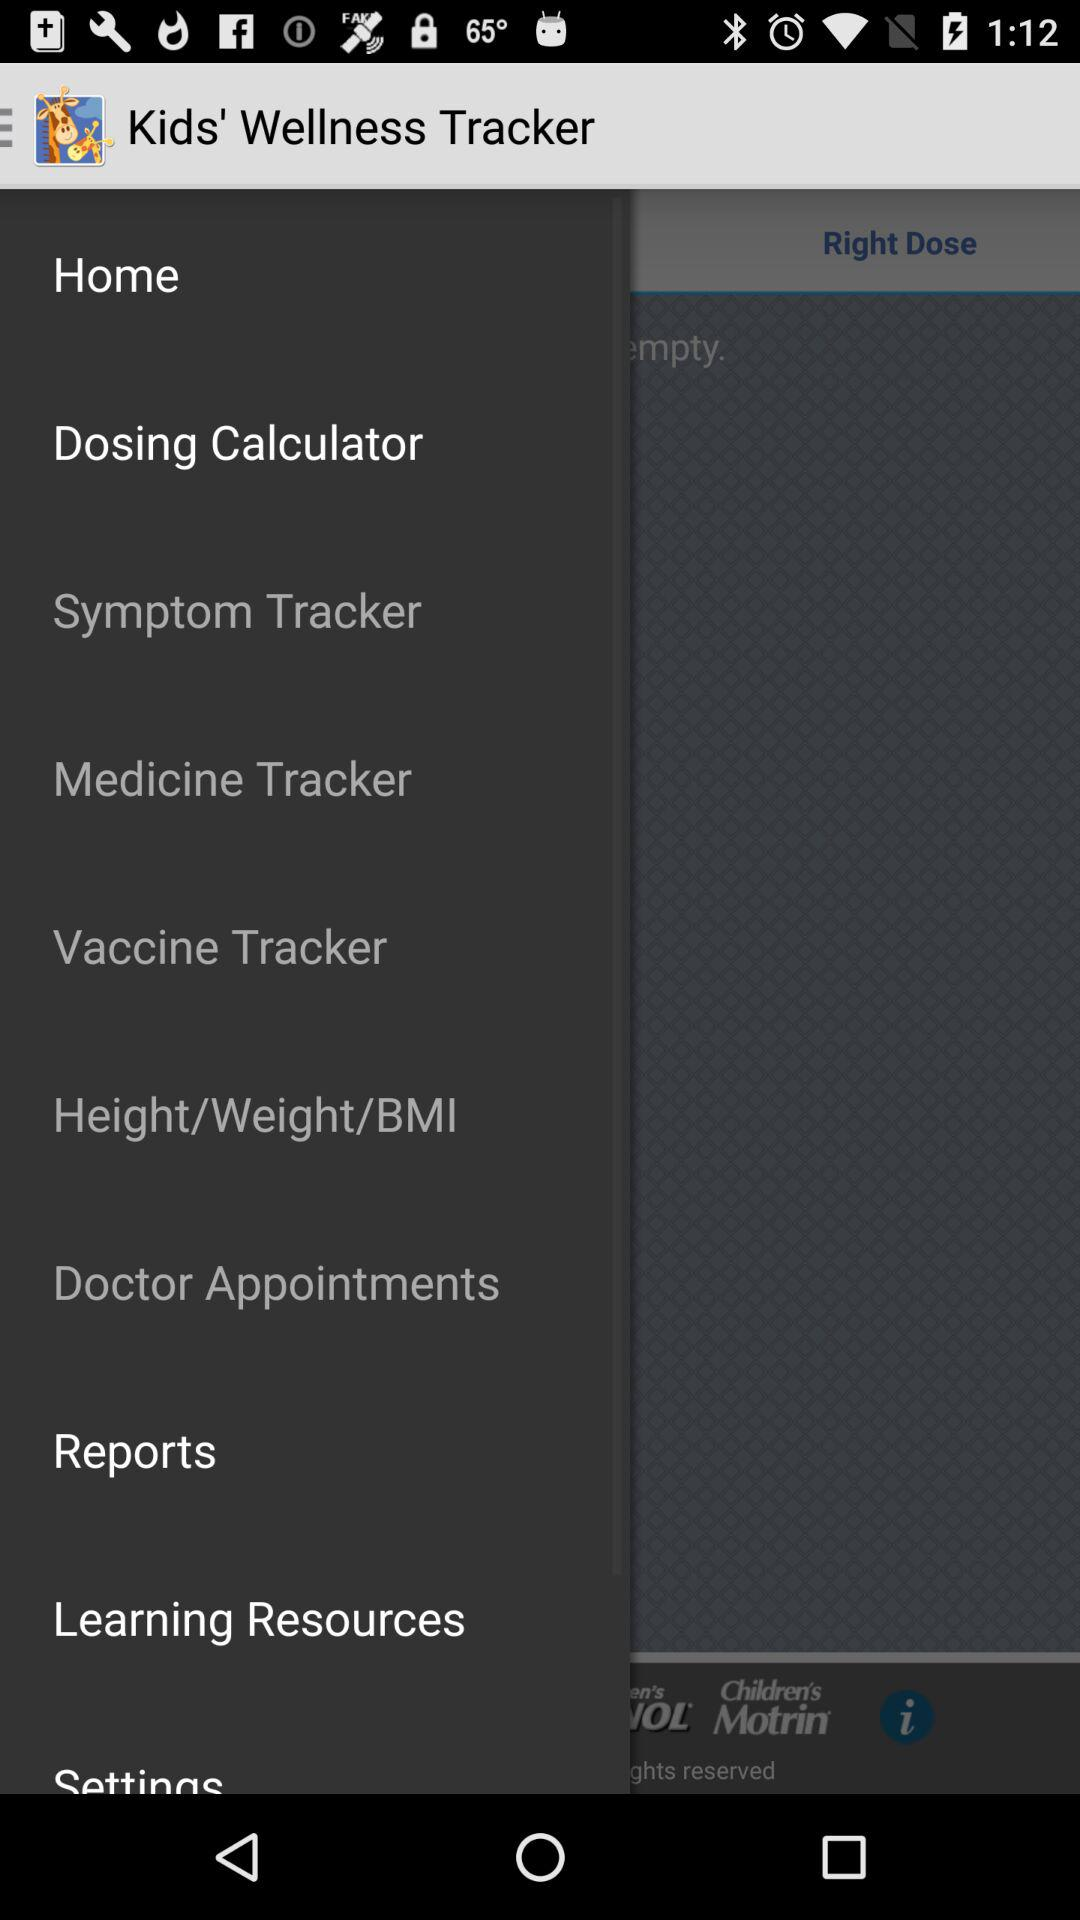What is the name of the application? The name of the application is "Kids' Wellness Tracker". 